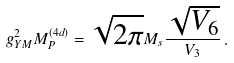<formula> <loc_0><loc_0><loc_500><loc_500>g _ { Y M } ^ { 2 } M _ { P } ^ { ( 4 d ) } = \sqrt { 2 \pi } M _ { s } \frac { \sqrt { V _ { 6 } } } { V _ { 3 } } \, .</formula> 